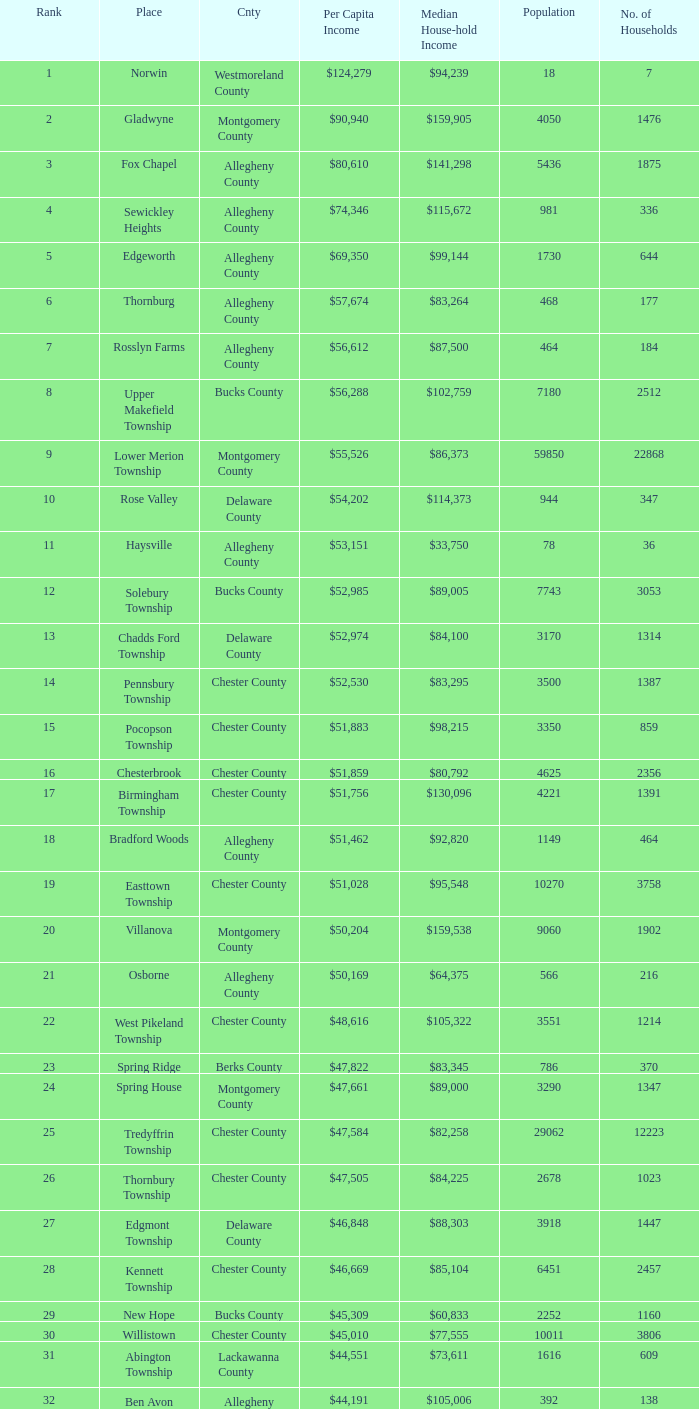Which county has a median household income of  $98,090? Bucks County. 